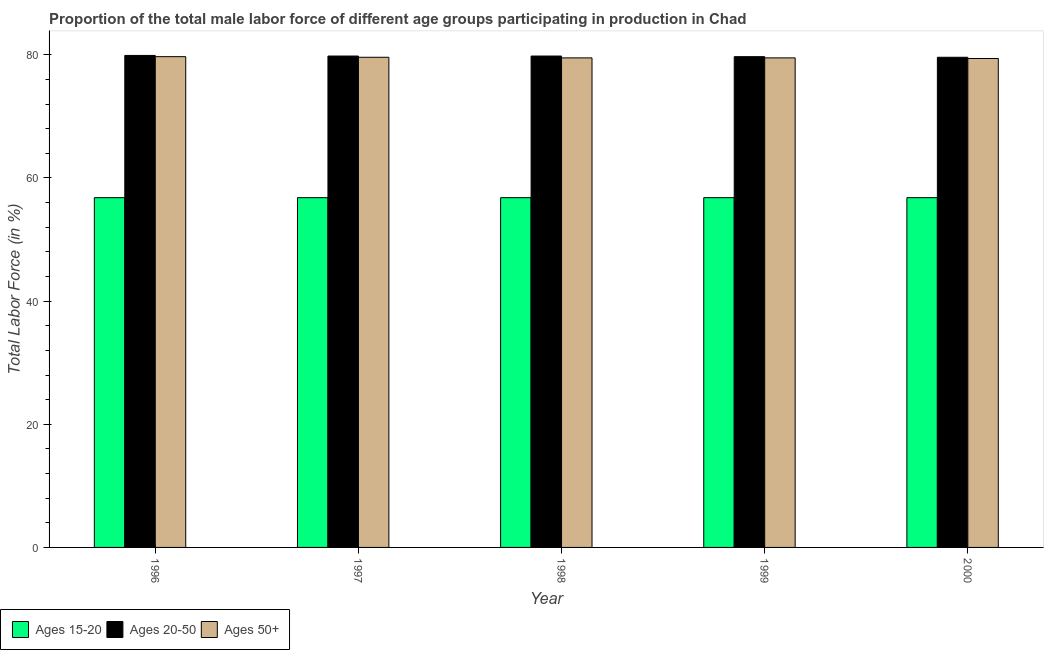Are the number of bars on each tick of the X-axis equal?
Provide a succinct answer. Yes. What is the percentage of male labor force within the age group 20-50 in 2000?
Give a very brief answer. 79.6. Across all years, what is the maximum percentage of male labor force within the age group 15-20?
Make the answer very short. 56.8. Across all years, what is the minimum percentage of male labor force within the age group 15-20?
Provide a succinct answer. 56.8. What is the total percentage of male labor force within the age group 15-20 in the graph?
Your answer should be very brief. 284. What is the difference between the percentage of male labor force within the age group 20-50 in 1996 and that in 2000?
Your answer should be very brief. 0.3. What is the difference between the percentage of male labor force within the age group 20-50 in 2000 and the percentage of male labor force above age 50 in 1997?
Offer a terse response. -0.2. What is the average percentage of male labor force within the age group 15-20 per year?
Your response must be concise. 56.8. In the year 1998, what is the difference between the percentage of male labor force within the age group 15-20 and percentage of male labor force above age 50?
Your answer should be very brief. 0. In how many years, is the percentage of male labor force within the age group 20-50 greater than 48 %?
Make the answer very short. 5. What is the ratio of the percentage of male labor force above age 50 in 1997 to that in 1999?
Your answer should be compact. 1. What is the difference between the highest and the lowest percentage of male labor force within the age group 20-50?
Ensure brevity in your answer.  0.3. In how many years, is the percentage of male labor force within the age group 20-50 greater than the average percentage of male labor force within the age group 20-50 taken over all years?
Your answer should be compact. 3. Is the sum of the percentage of male labor force above age 50 in 1998 and 2000 greater than the maximum percentage of male labor force within the age group 15-20 across all years?
Offer a terse response. Yes. What does the 2nd bar from the left in 2000 represents?
Your response must be concise. Ages 20-50. What does the 1st bar from the right in 2000 represents?
Your answer should be very brief. Ages 50+. How many bars are there?
Provide a short and direct response. 15. What is the difference between two consecutive major ticks on the Y-axis?
Ensure brevity in your answer.  20. Where does the legend appear in the graph?
Your response must be concise. Bottom left. How are the legend labels stacked?
Ensure brevity in your answer.  Horizontal. What is the title of the graph?
Provide a short and direct response. Proportion of the total male labor force of different age groups participating in production in Chad. Does "Transport equipments" appear as one of the legend labels in the graph?
Make the answer very short. No. What is the Total Labor Force (in %) in Ages 15-20 in 1996?
Your answer should be very brief. 56.8. What is the Total Labor Force (in %) in Ages 20-50 in 1996?
Your response must be concise. 79.9. What is the Total Labor Force (in %) of Ages 50+ in 1996?
Provide a succinct answer. 79.7. What is the Total Labor Force (in %) in Ages 15-20 in 1997?
Offer a very short reply. 56.8. What is the Total Labor Force (in %) in Ages 20-50 in 1997?
Give a very brief answer. 79.8. What is the Total Labor Force (in %) of Ages 50+ in 1997?
Provide a short and direct response. 79.6. What is the Total Labor Force (in %) of Ages 15-20 in 1998?
Offer a very short reply. 56.8. What is the Total Labor Force (in %) in Ages 20-50 in 1998?
Offer a terse response. 79.8. What is the Total Labor Force (in %) in Ages 50+ in 1998?
Provide a short and direct response. 79.5. What is the Total Labor Force (in %) of Ages 15-20 in 1999?
Offer a terse response. 56.8. What is the Total Labor Force (in %) of Ages 20-50 in 1999?
Your response must be concise. 79.7. What is the Total Labor Force (in %) of Ages 50+ in 1999?
Your answer should be compact. 79.5. What is the Total Labor Force (in %) in Ages 15-20 in 2000?
Your answer should be compact. 56.8. What is the Total Labor Force (in %) in Ages 20-50 in 2000?
Give a very brief answer. 79.6. What is the Total Labor Force (in %) of Ages 50+ in 2000?
Provide a succinct answer. 79.4. Across all years, what is the maximum Total Labor Force (in %) in Ages 15-20?
Your answer should be compact. 56.8. Across all years, what is the maximum Total Labor Force (in %) of Ages 20-50?
Ensure brevity in your answer.  79.9. Across all years, what is the maximum Total Labor Force (in %) of Ages 50+?
Keep it short and to the point. 79.7. Across all years, what is the minimum Total Labor Force (in %) in Ages 15-20?
Provide a succinct answer. 56.8. Across all years, what is the minimum Total Labor Force (in %) in Ages 20-50?
Keep it short and to the point. 79.6. Across all years, what is the minimum Total Labor Force (in %) of Ages 50+?
Your answer should be compact. 79.4. What is the total Total Labor Force (in %) in Ages 15-20 in the graph?
Keep it short and to the point. 284. What is the total Total Labor Force (in %) in Ages 20-50 in the graph?
Offer a terse response. 398.8. What is the total Total Labor Force (in %) of Ages 50+ in the graph?
Give a very brief answer. 397.7. What is the difference between the Total Labor Force (in %) in Ages 15-20 in 1996 and that in 1997?
Give a very brief answer. 0. What is the difference between the Total Labor Force (in %) in Ages 20-50 in 1996 and that in 1997?
Offer a terse response. 0.1. What is the difference between the Total Labor Force (in %) in Ages 15-20 in 1996 and that in 1998?
Make the answer very short. 0. What is the difference between the Total Labor Force (in %) in Ages 20-50 in 1996 and that in 1998?
Make the answer very short. 0.1. What is the difference between the Total Labor Force (in %) of Ages 20-50 in 1996 and that in 1999?
Offer a terse response. 0.2. What is the difference between the Total Labor Force (in %) of Ages 50+ in 1996 and that in 1999?
Your answer should be compact. 0.2. What is the difference between the Total Labor Force (in %) of Ages 15-20 in 1996 and that in 2000?
Make the answer very short. 0. What is the difference between the Total Labor Force (in %) in Ages 20-50 in 1996 and that in 2000?
Keep it short and to the point. 0.3. What is the difference between the Total Labor Force (in %) in Ages 50+ in 1996 and that in 2000?
Give a very brief answer. 0.3. What is the difference between the Total Labor Force (in %) of Ages 15-20 in 1997 and that in 1999?
Give a very brief answer. 0. What is the difference between the Total Labor Force (in %) of Ages 20-50 in 1997 and that in 1999?
Give a very brief answer. 0.1. What is the difference between the Total Labor Force (in %) in Ages 50+ in 1997 and that in 1999?
Keep it short and to the point. 0.1. What is the difference between the Total Labor Force (in %) of Ages 15-20 in 1997 and that in 2000?
Give a very brief answer. 0. What is the difference between the Total Labor Force (in %) of Ages 20-50 in 1997 and that in 2000?
Make the answer very short. 0.2. What is the difference between the Total Labor Force (in %) of Ages 15-20 in 1998 and that in 1999?
Offer a terse response. 0. What is the difference between the Total Labor Force (in %) of Ages 20-50 in 1998 and that in 1999?
Your answer should be compact. 0.1. What is the difference between the Total Labor Force (in %) in Ages 50+ in 1998 and that in 1999?
Your response must be concise. 0. What is the difference between the Total Labor Force (in %) in Ages 50+ in 1998 and that in 2000?
Keep it short and to the point. 0.1. What is the difference between the Total Labor Force (in %) in Ages 15-20 in 1999 and that in 2000?
Give a very brief answer. 0. What is the difference between the Total Labor Force (in %) of Ages 50+ in 1999 and that in 2000?
Keep it short and to the point. 0.1. What is the difference between the Total Labor Force (in %) in Ages 15-20 in 1996 and the Total Labor Force (in %) in Ages 50+ in 1997?
Offer a very short reply. -22.8. What is the difference between the Total Labor Force (in %) of Ages 15-20 in 1996 and the Total Labor Force (in %) of Ages 20-50 in 1998?
Your response must be concise. -23. What is the difference between the Total Labor Force (in %) of Ages 15-20 in 1996 and the Total Labor Force (in %) of Ages 50+ in 1998?
Your answer should be compact. -22.7. What is the difference between the Total Labor Force (in %) of Ages 15-20 in 1996 and the Total Labor Force (in %) of Ages 20-50 in 1999?
Your response must be concise. -22.9. What is the difference between the Total Labor Force (in %) in Ages 15-20 in 1996 and the Total Labor Force (in %) in Ages 50+ in 1999?
Ensure brevity in your answer.  -22.7. What is the difference between the Total Labor Force (in %) in Ages 20-50 in 1996 and the Total Labor Force (in %) in Ages 50+ in 1999?
Ensure brevity in your answer.  0.4. What is the difference between the Total Labor Force (in %) in Ages 15-20 in 1996 and the Total Labor Force (in %) in Ages 20-50 in 2000?
Offer a terse response. -22.8. What is the difference between the Total Labor Force (in %) in Ages 15-20 in 1996 and the Total Labor Force (in %) in Ages 50+ in 2000?
Keep it short and to the point. -22.6. What is the difference between the Total Labor Force (in %) of Ages 15-20 in 1997 and the Total Labor Force (in %) of Ages 50+ in 1998?
Offer a terse response. -22.7. What is the difference between the Total Labor Force (in %) in Ages 20-50 in 1997 and the Total Labor Force (in %) in Ages 50+ in 1998?
Your answer should be compact. 0.3. What is the difference between the Total Labor Force (in %) of Ages 15-20 in 1997 and the Total Labor Force (in %) of Ages 20-50 in 1999?
Keep it short and to the point. -22.9. What is the difference between the Total Labor Force (in %) of Ages 15-20 in 1997 and the Total Labor Force (in %) of Ages 50+ in 1999?
Give a very brief answer. -22.7. What is the difference between the Total Labor Force (in %) of Ages 15-20 in 1997 and the Total Labor Force (in %) of Ages 20-50 in 2000?
Ensure brevity in your answer.  -22.8. What is the difference between the Total Labor Force (in %) in Ages 15-20 in 1997 and the Total Labor Force (in %) in Ages 50+ in 2000?
Give a very brief answer. -22.6. What is the difference between the Total Labor Force (in %) in Ages 15-20 in 1998 and the Total Labor Force (in %) in Ages 20-50 in 1999?
Offer a terse response. -22.9. What is the difference between the Total Labor Force (in %) in Ages 15-20 in 1998 and the Total Labor Force (in %) in Ages 50+ in 1999?
Make the answer very short. -22.7. What is the difference between the Total Labor Force (in %) of Ages 20-50 in 1998 and the Total Labor Force (in %) of Ages 50+ in 1999?
Offer a terse response. 0.3. What is the difference between the Total Labor Force (in %) of Ages 15-20 in 1998 and the Total Labor Force (in %) of Ages 20-50 in 2000?
Offer a very short reply. -22.8. What is the difference between the Total Labor Force (in %) in Ages 15-20 in 1998 and the Total Labor Force (in %) in Ages 50+ in 2000?
Your answer should be very brief. -22.6. What is the difference between the Total Labor Force (in %) of Ages 15-20 in 1999 and the Total Labor Force (in %) of Ages 20-50 in 2000?
Provide a short and direct response. -22.8. What is the difference between the Total Labor Force (in %) in Ages 15-20 in 1999 and the Total Labor Force (in %) in Ages 50+ in 2000?
Offer a terse response. -22.6. What is the average Total Labor Force (in %) of Ages 15-20 per year?
Offer a terse response. 56.8. What is the average Total Labor Force (in %) of Ages 20-50 per year?
Make the answer very short. 79.76. What is the average Total Labor Force (in %) of Ages 50+ per year?
Keep it short and to the point. 79.54. In the year 1996, what is the difference between the Total Labor Force (in %) of Ages 15-20 and Total Labor Force (in %) of Ages 20-50?
Make the answer very short. -23.1. In the year 1996, what is the difference between the Total Labor Force (in %) in Ages 15-20 and Total Labor Force (in %) in Ages 50+?
Make the answer very short. -22.9. In the year 1996, what is the difference between the Total Labor Force (in %) of Ages 20-50 and Total Labor Force (in %) of Ages 50+?
Provide a succinct answer. 0.2. In the year 1997, what is the difference between the Total Labor Force (in %) in Ages 15-20 and Total Labor Force (in %) in Ages 50+?
Keep it short and to the point. -22.8. In the year 1998, what is the difference between the Total Labor Force (in %) in Ages 15-20 and Total Labor Force (in %) in Ages 50+?
Keep it short and to the point. -22.7. In the year 1998, what is the difference between the Total Labor Force (in %) in Ages 20-50 and Total Labor Force (in %) in Ages 50+?
Your response must be concise. 0.3. In the year 1999, what is the difference between the Total Labor Force (in %) in Ages 15-20 and Total Labor Force (in %) in Ages 20-50?
Ensure brevity in your answer.  -22.9. In the year 1999, what is the difference between the Total Labor Force (in %) in Ages 15-20 and Total Labor Force (in %) in Ages 50+?
Your answer should be very brief. -22.7. In the year 2000, what is the difference between the Total Labor Force (in %) of Ages 15-20 and Total Labor Force (in %) of Ages 20-50?
Offer a terse response. -22.8. In the year 2000, what is the difference between the Total Labor Force (in %) in Ages 15-20 and Total Labor Force (in %) in Ages 50+?
Provide a succinct answer. -22.6. What is the ratio of the Total Labor Force (in %) of Ages 20-50 in 1996 to that in 1997?
Your answer should be compact. 1. What is the ratio of the Total Labor Force (in %) of Ages 50+ in 1996 to that in 1998?
Provide a short and direct response. 1. What is the ratio of the Total Labor Force (in %) in Ages 20-50 in 1996 to that in 1999?
Your response must be concise. 1. What is the ratio of the Total Labor Force (in %) in Ages 50+ in 1996 to that in 1999?
Offer a very short reply. 1. What is the ratio of the Total Labor Force (in %) in Ages 15-20 in 1996 to that in 2000?
Offer a very short reply. 1. What is the ratio of the Total Labor Force (in %) of Ages 20-50 in 1996 to that in 2000?
Keep it short and to the point. 1. What is the ratio of the Total Labor Force (in %) in Ages 15-20 in 1997 to that in 1998?
Make the answer very short. 1. What is the ratio of the Total Labor Force (in %) of Ages 50+ in 1997 to that in 1998?
Offer a very short reply. 1. What is the ratio of the Total Labor Force (in %) of Ages 15-20 in 1997 to that in 1999?
Your answer should be very brief. 1. What is the ratio of the Total Labor Force (in %) in Ages 20-50 in 1997 to that in 1999?
Your answer should be compact. 1. What is the ratio of the Total Labor Force (in %) in Ages 50+ in 1997 to that in 1999?
Offer a very short reply. 1. What is the ratio of the Total Labor Force (in %) in Ages 20-50 in 1997 to that in 2000?
Ensure brevity in your answer.  1. What is the ratio of the Total Labor Force (in %) of Ages 50+ in 1997 to that in 2000?
Your answer should be very brief. 1. What is the ratio of the Total Labor Force (in %) in Ages 15-20 in 1998 to that in 1999?
Your response must be concise. 1. What is the ratio of the Total Labor Force (in %) of Ages 15-20 in 1998 to that in 2000?
Your answer should be compact. 1. What is the ratio of the Total Labor Force (in %) in Ages 50+ in 1998 to that in 2000?
Offer a terse response. 1. What is the ratio of the Total Labor Force (in %) in Ages 15-20 in 1999 to that in 2000?
Offer a very short reply. 1. What is the ratio of the Total Labor Force (in %) in Ages 20-50 in 1999 to that in 2000?
Make the answer very short. 1. What is the difference between the highest and the lowest Total Labor Force (in %) of Ages 15-20?
Your response must be concise. 0. 